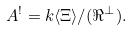Convert formula to latex. <formula><loc_0><loc_0><loc_500><loc_500>A ^ { ! } = k \langle \Xi \rangle / ( \Re ^ { \bot } ) .</formula> 